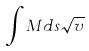Convert formula to latex. <formula><loc_0><loc_0><loc_500><loc_500>\int M d s \sqrt { v }</formula> 